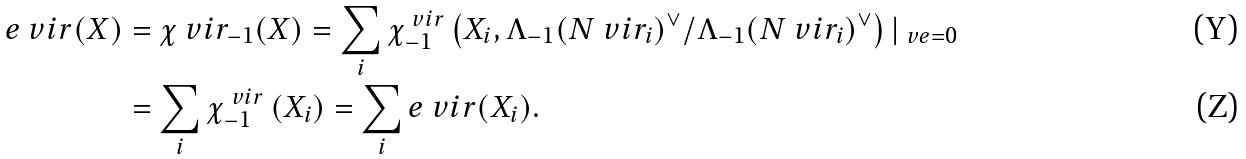Convert formula to latex. <formula><loc_0><loc_0><loc_500><loc_500>e ^ { \ } v i r ( X ) & = \chi ^ { \ } v i r _ { - 1 } ( X ) = \sum _ { i } \chi _ { - 1 } ^ { \ v i r } \left ( X _ { i } , \Lambda _ { - 1 } ( N ^ { \ } v i r _ { i } ) ^ { \vee } / \Lambda _ { - 1 } ( N ^ { \ } v i r _ { i } ) ^ { \vee } \right ) | _ { \ v e = 0 } \\ & = \sum _ { i } \chi _ { - 1 } ^ { \ v i r } \left ( X _ { i } \right ) = \sum _ { i } e ^ { \ } v i r ( X _ { i } ) .</formula> 